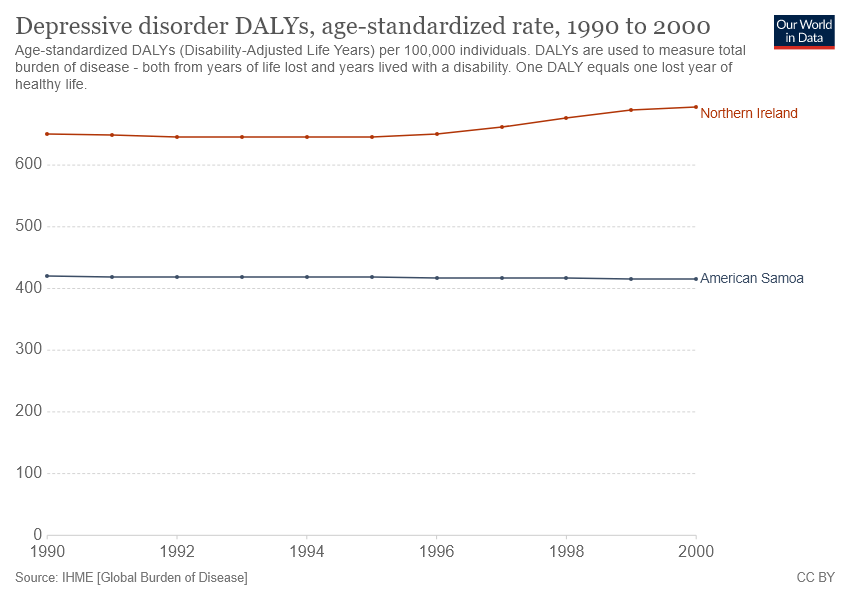Highlight a few significant elements in this photo. Northern Ireland has recorded higher depressive disorder DALYs than American Samoa over the years. In the year 2000, the highest number of depressive disorder DALYs was recorded in Northern Ireland. 